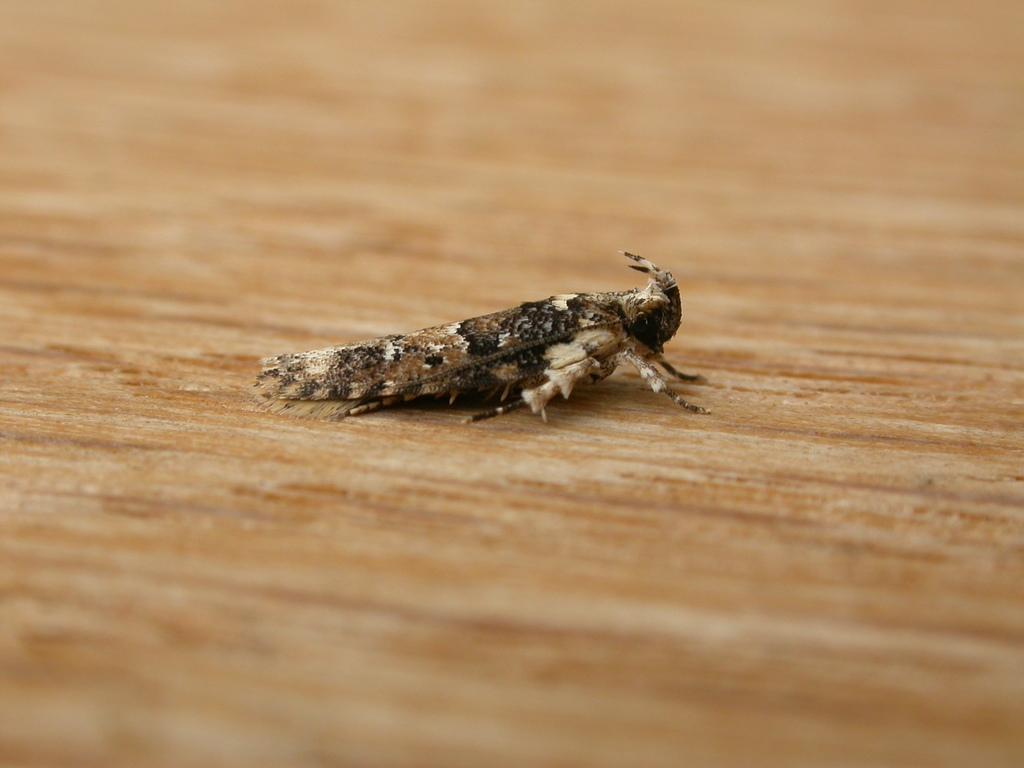Describe this image in one or two sentences. In this image there is a fly in the center which is on the brown colour surface. 